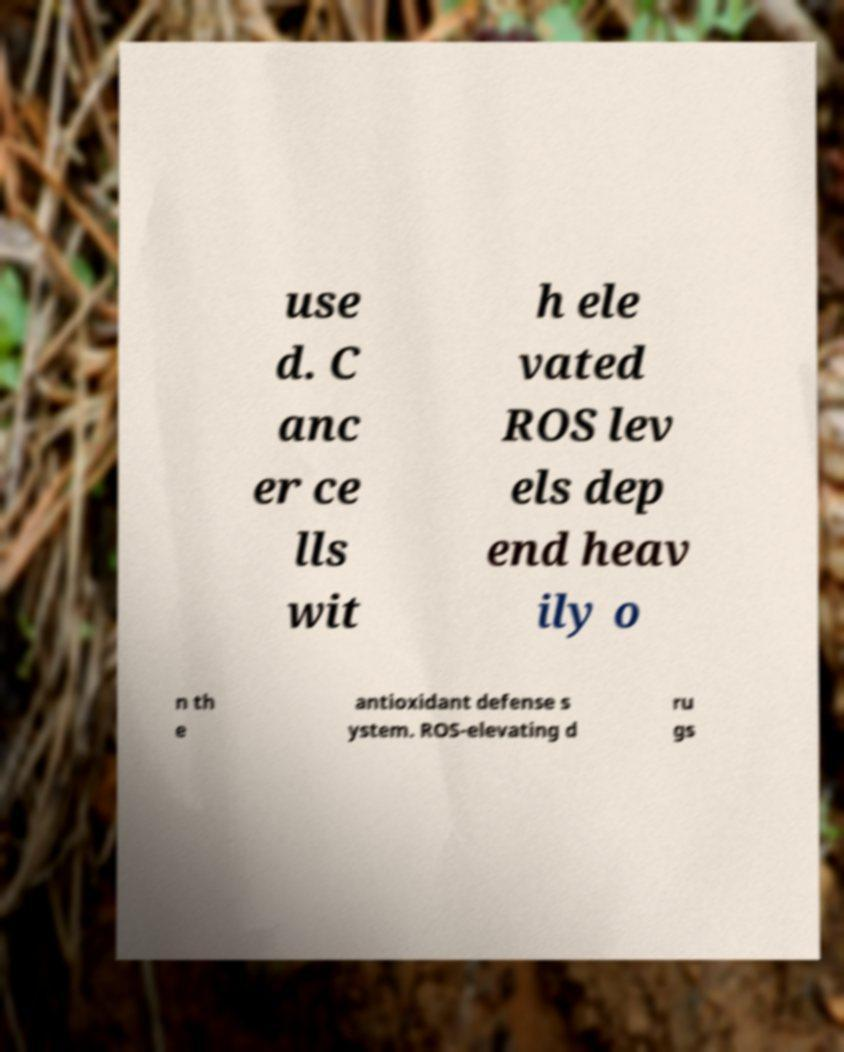Could you extract and type out the text from this image? use d. C anc er ce lls wit h ele vated ROS lev els dep end heav ily o n th e antioxidant defense s ystem. ROS-elevating d ru gs 